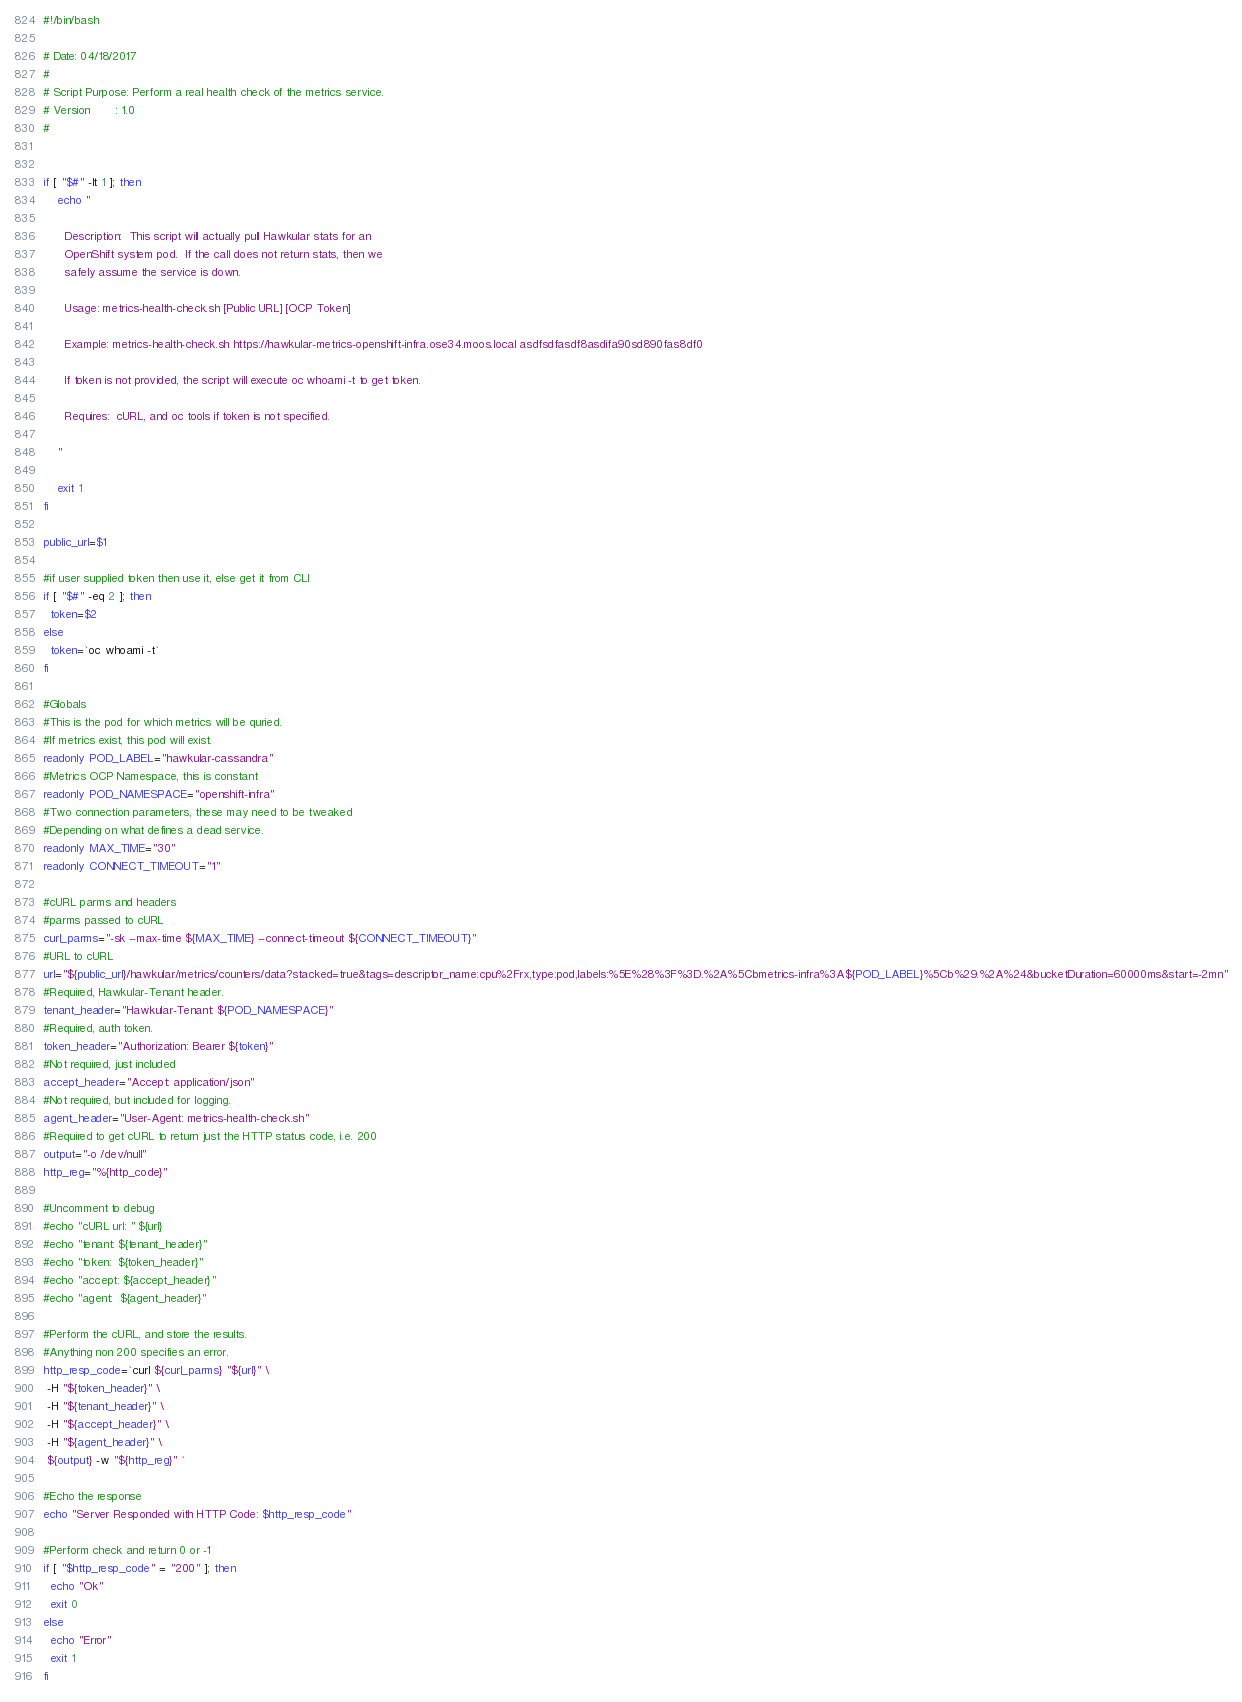Convert code to text. <code><loc_0><loc_0><loc_500><loc_500><_Bash_>#!/bin/bash

# Date: 04/18/2017
#
# Script Purpose: Perform a real health check of the metrics service.
# Version       : 1.0
#


if [ "$#" -lt 1 ]; then
    echo "

      Description:  This script will actually pull Hawkular stats for an
      OpenShift system pod.  If the call does not return stats, then we
      safely assume the service is down.

      Usage: metrics-health-check.sh [Public URL] [OCP Token]

      Example: metrics-health-check.sh https://hawkular-metrics-openshift-infra.ose34.moos.local asdfsdfasdf8asdifa90sd890fas8df0

      If token is not provided, the script will execute oc whoami -t to get token.

      Requires:  cURL, and oc tools if token is not specified.

    "

    exit 1
fi

public_url=$1

#if user supplied token then use it, else get it from CLI
if [ "$#" -eq 2 ]; then
  token=$2
else
  token=`oc whoami -t`
fi

#Globals
#This is the pod for which metrics will be quried.
#If metrics exist, this pod will exist.
readonly POD_LABEL="hawkular-cassandra"
#Metrics OCP Namespace, this is constant
readonly POD_NAMESPACE="openshift-infra"
#Two connection parameters, these may need to be tweaked
#Depending on what defines a dead service.
readonly MAX_TIME="30"
readonly CONNECT_TIMEOUT="1"

#cURL parms and headers
#parms passed to cURL
curl_parms="-sk --max-time ${MAX_TIME} --connect-timeout ${CONNECT_TIMEOUT}"
#URL to cURL
url="${public_url}/hawkular/metrics/counters/data?stacked=true&tags=descriptor_name:cpu%2Frx,type:pod,labels:%5E%28%3F%3D.%2A%5Cbmetrics-infra%3A${POD_LABEL}%5Cb%29.%2A%24&bucketDuration=60000ms&start=-2mn"
#Required, Hawkular-Tenant header.
tenant_header="Hawkular-Tenant: ${POD_NAMESPACE}"
#Required, auth token.
token_header="Authorization: Bearer ${token}"
#Not required, just included
accept_header="Accept: application/json"
#Not required, but included for logging.
agent_header="User-Agent: metrics-health-check.sh"
#Required to get cURL to return just the HTTP status code, i.e. 200
output="-o /dev/null"
http_reg="%{http_code}"

#Uncomment to debug
#echo "cURL url: " ${url}
#echo "tenant: ${tenant_header}"
#echo "token:  ${token_header}"
#echo "accept: ${accept_header}"
#echo "agent:  ${agent_header}"

#Perform the cURL, and store the results.
#Anything non 200 specifies an error.
http_resp_code=`curl ${curl_parms} "${url}" \
 -H "${token_header}" \
 -H "${tenant_header}" \
 -H "${accept_header}" \
 -H "${agent_header}" \
 ${output} -w "${http_reg}" `

#Echo the response
echo "Server Responded with HTTP Code: $http_resp_code"

#Perform check and return 0 or -1
if [ "$http_resp_code" = "200" ]; then
  echo "Ok"
  exit 0
else
  echo "Error"
  exit 1
fi
</code> 